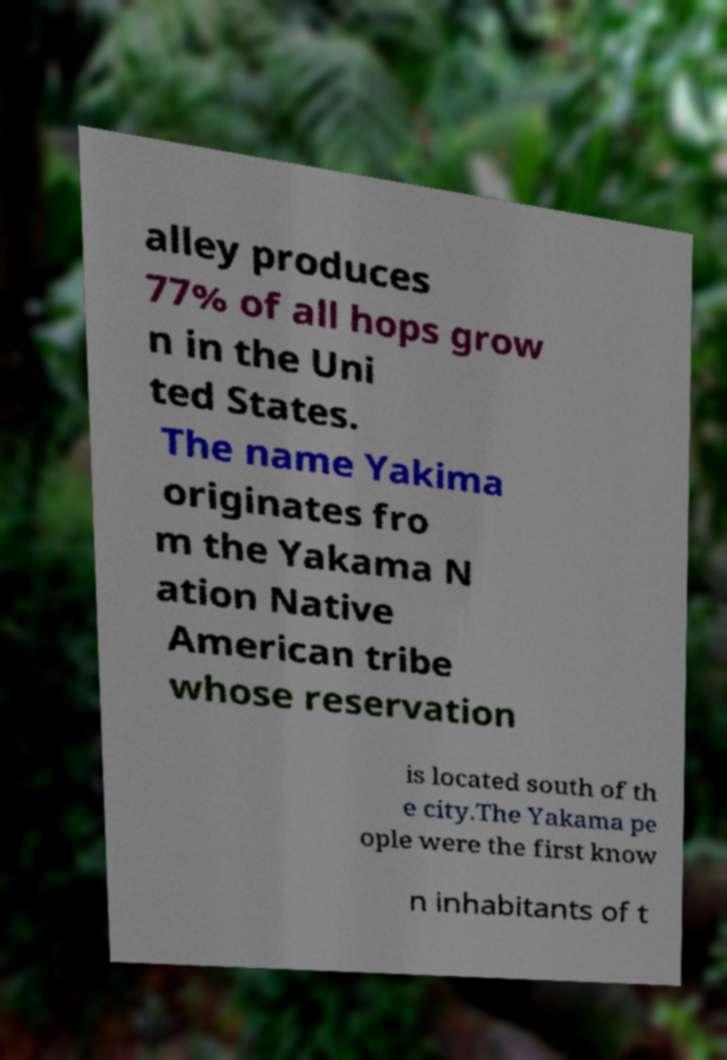Please identify and transcribe the text found in this image. alley produces 77% of all hops grow n in the Uni ted States. The name Yakima originates fro m the Yakama N ation Native American tribe whose reservation is located south of th e city.The Yakama pe ople were the first know n inhabitants of t 